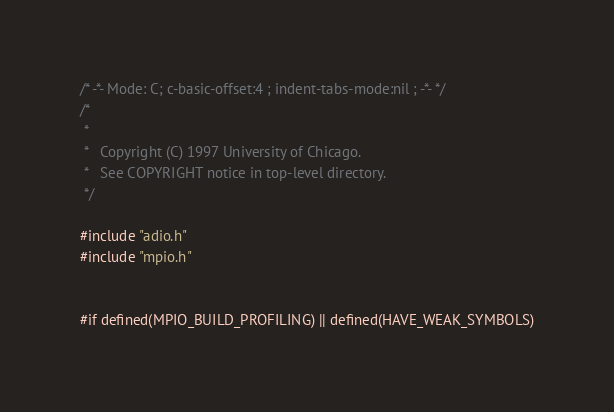<code> <loc_0><loc_0><loc_500><loc_500><_C_>/* -*- Mode: C; c-basic-offset:4 ; indent-tabs-mode:nil ; -*- */
/* 
 *
 *   Copyright (C) 1997 University of Chicago. 
 *   See COPYRIGHT notice in top-level directory.
 */

#include "adio.h"
#include "mpio.h"


#if defined(MPIO_BUILD_PROFILING) || defined(HAVE_WEAK_SYMBOLS)
</code> 